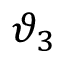Convert formula to latex. <formula><loc_0><loc_0><loc_500><loc_500>\vartheta _ { 3 }</formula> 